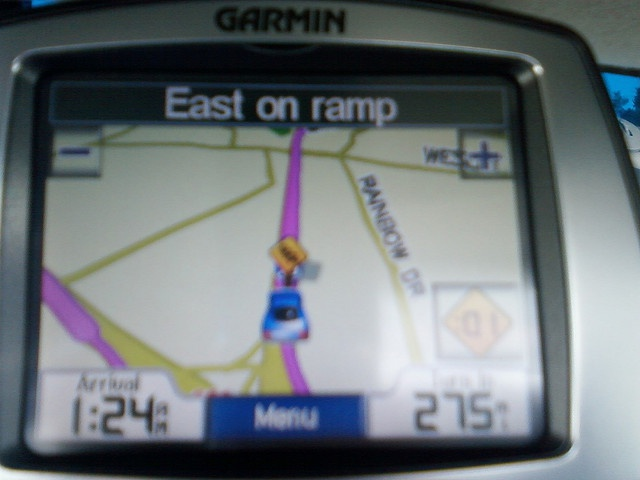Describe the objects in this image and their specific colors. I can see a cell phone in darkgray, black, gray, and lightgray tones in this image. 